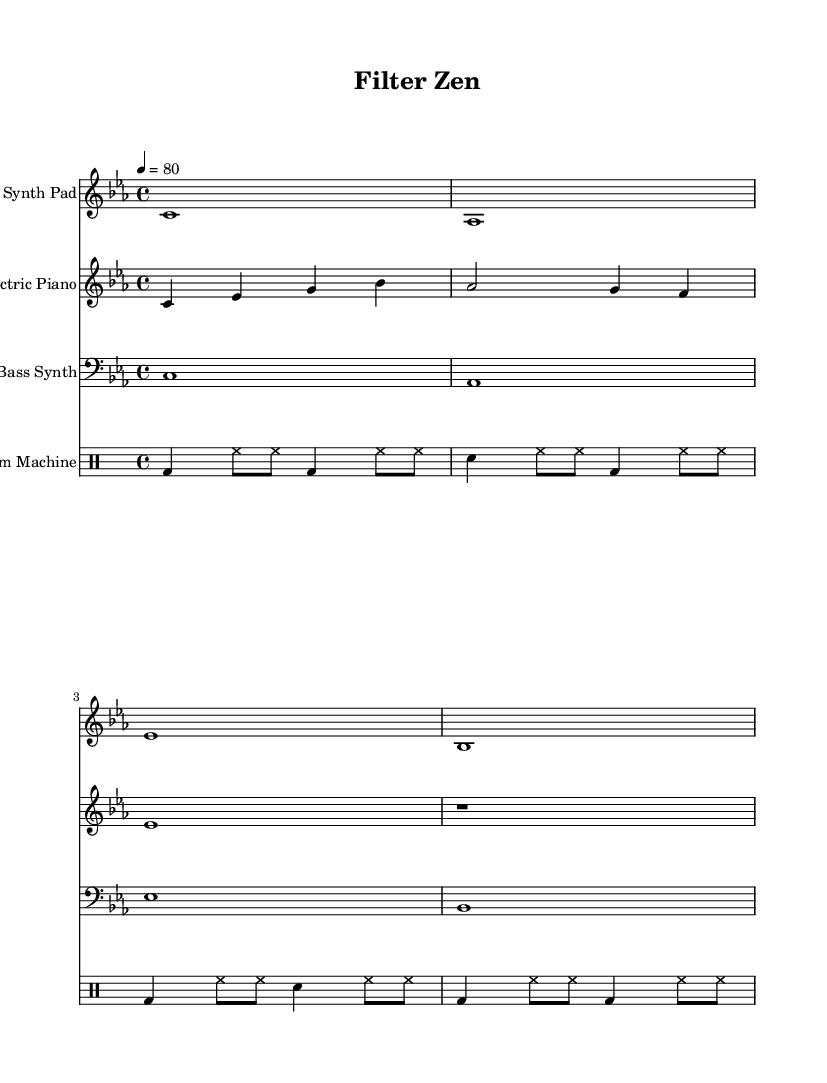What is the key signature of this music? The key signature is identified by the sharp and flat symbols at the beginning of the staff. In this case, there are no sharps or flats indicated, which shows it is in C minor.
Answer: C minor What is the tempo marking given in the piece? The tempo marking is indicated at the beginning of the score, showing a quarter note equals 80 beats per minute.
Answer: 80 How many measures are in the Synth Pad staff? Counting the measures in the Synth Pad staff provides us with one measure per each bar line. There are four distinct notes, indicating four measures.
Answer: 4 What type of musical piece is this? This piece is categorized under the genre of Electronic music, specifically downtempo, due to its chill and relaxing atmosphere, which is conducive to unwinding.
Answer: Downtempo electronic What is the time signature indicated in this music? The time signature is shown at the beginning of the score, where the top number indicates four beats per measure and the bottom indicates a quarter note gets one beat. This signifies a 4/4 time signature.
Answer: 4/4 How many staves are present in the score? By observing the score layout, we note there are four distinct staves for the different instruments. Each instrument is scored separately, creating a total of four staves.
Answer: 4 Which instrument plays the bass line in this score? The bass line is indicated by the staff labeled "Bass Synth," which shows the lower notes typical for a bass instrument in electronic music.
Answer: Bass Synth 